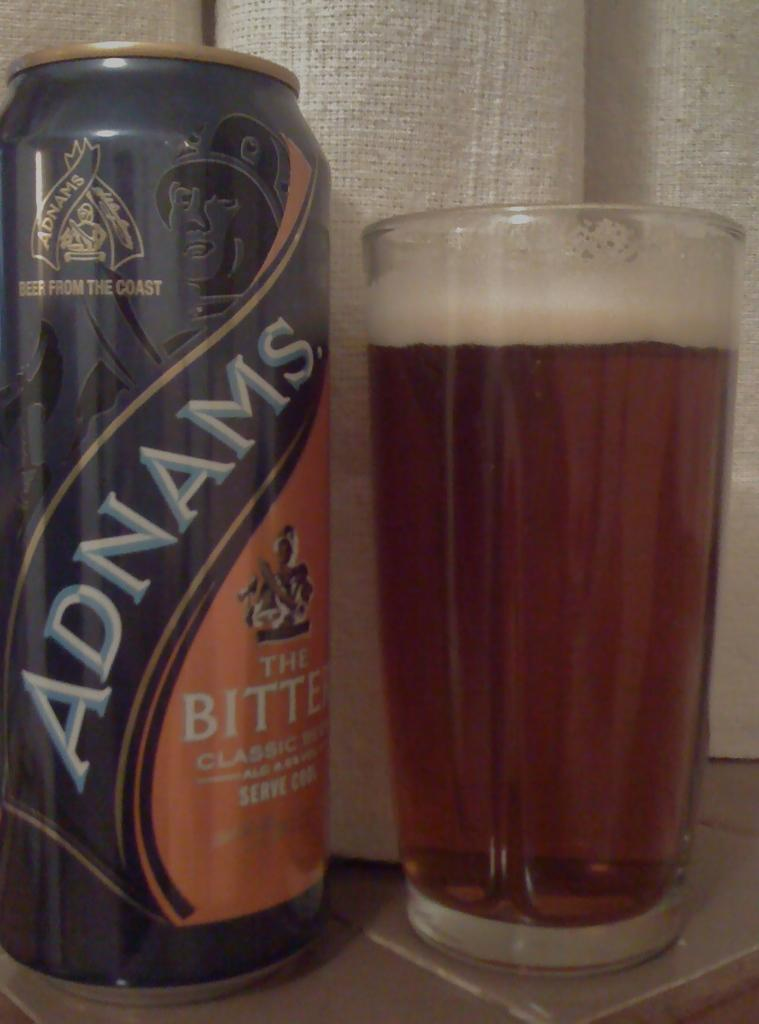Provide a one-sentence caption for the provided image. A can of Adnams beer next to a glass full of beer. 